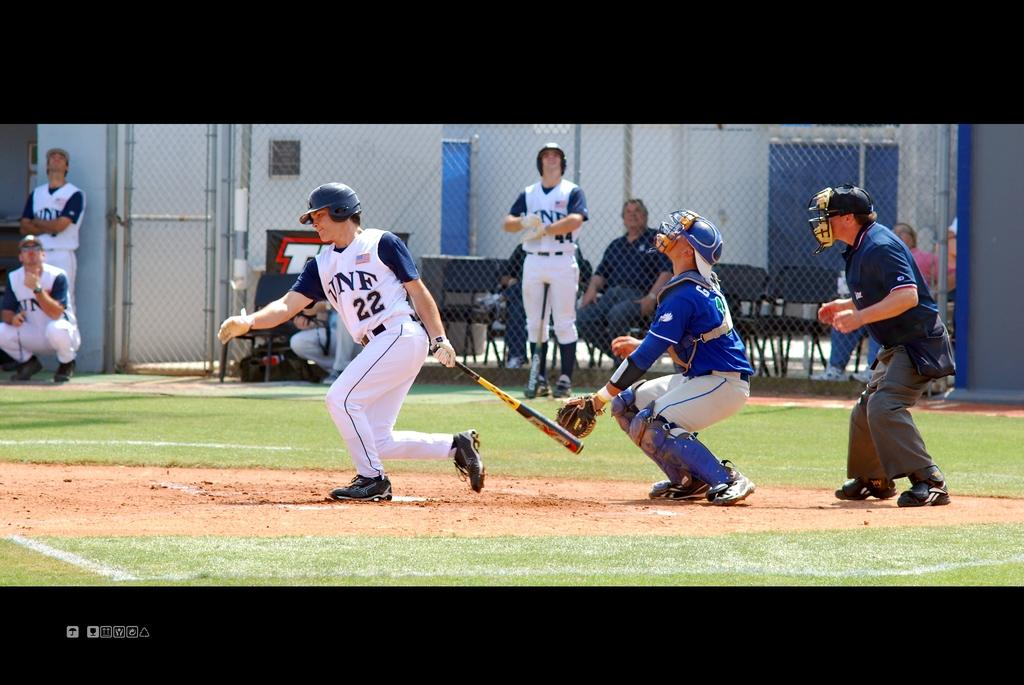<image>
Write a terse but informative summary of the picture. number 22 for VNF hits the ball and catcher looks up for it 